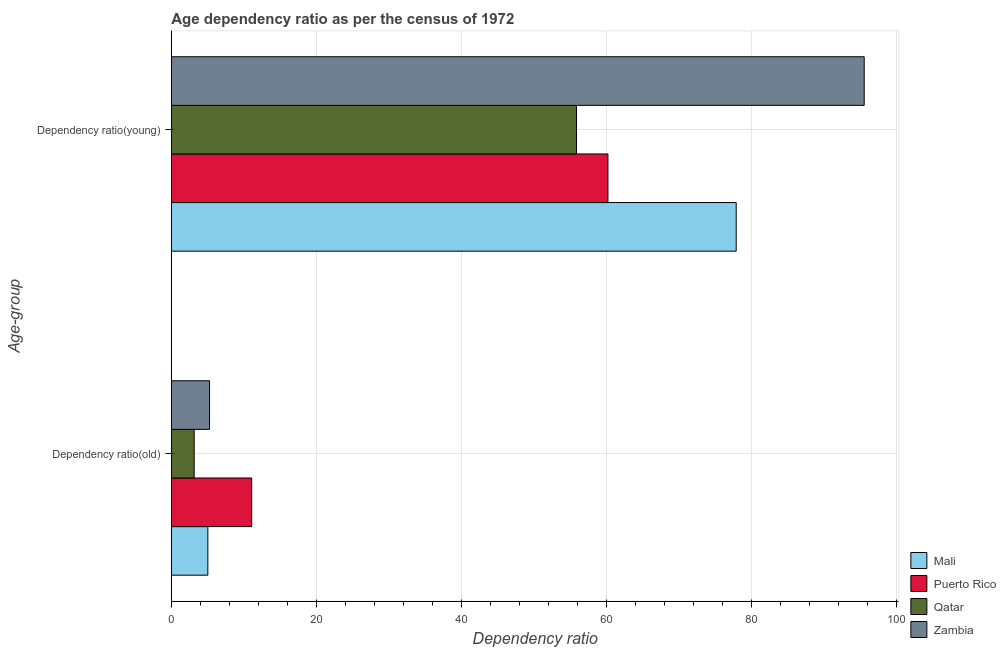How many different coloured bars are there?
Your answer should be very brief. 4. How many groups of bars are there?
Offer a terse response. 2. Are the number of bars per tick equal to the number of legend labels?
Give a very brief answer. Yes. Are the number of bars on each tick of the Y-axis equal?
Make the answer very short. Yes. How many bars are there on the 1st tick from the bottom?
Provide a succinct answer. 4. What is the label of the 1st group of bars from the top?
Make the answer very short. Dependency ratio(young). What is the age dependency ratio(old) in Mali?
Keep it short and to the point. 5.03. Across all countries, what is the maximum age dependency ratio(old)?
Provide a short and direct response. 11.08. Across all countries, what is the minimum age dependency ratio(old)?
Offer a terse response. 3.14. In which country was the age dependency ratio(old) maximum?
Offer a very short reply. Puerto Rico. In which country was the age dependency ratio(old) minimum?
Offer a terse response. Qatar. What is the total age dependency ratio(young) in the graph?
Keep it short and to the point. 289.58. What is the difference between the age dependency ratio(young) in Qatar and that in Zambia?
Your answer should be compact. -39.69. What is the difference between the age dependency ratio(young) in Puerto Rico and the age dependency ratio(old) in Mali?
Provide a succinct answer. 55.19. What is the average age dependency ratio(old) per country?
Keep it short and to the point. 6.13. What is the difference between the age dependency ratio(young) and age dependency ratio(old) in Zambia?
Your answer should be very brief. 90.3. What is the ratio of the age dependency ratio(old) in Puerto Rico to that in Zambia?
Your answer should be compact. 2.1. Is the age dependency ratio(young) in Zambia less than that in Qatar?
Your answer should be very brief. No. In how many countries, is the age dependency ratio(old) greater than the average age dependency ratio(old) taken over all countries?
Provide a succinct answer. 1. What does the 4th bar from the top in Dependency ratio(young) represents?
Give a very brief answer. Mali. What does the 1st bar from the bottom in Dependency ratio(young) represents?
Your answer should be very brief. Mali. Does the graph contain any zero values?
Ensure brevity in your answer.  No. Does the graph contain grids?
Keep it short and to the point. Yes. Where does the legend appear in the graph?
Give a very brief answer. Bottom right. What is the title of the graph?
Provide a short and direct response. Age dependency ratio as per the census of 1972. What is the label or title of the X-axis?
Offer a very short reply. Dependency ratio. What is the label or title of the Y-axis?
Offer a terse response. Age-group. What is the Dependency ratio of Mali in Dependency ratio(old)?
Provide a short and direct response. 5.03. What is the Dependency ratio in Puerto Rico in Dependency ratio(old)?
Make the answer very short. 11.08. What is the Dependency ratio in Qatar in Dependency ratio(old)?
Give a very brief answer. 3.14. What is the Dependency ratio in Zambia in Dependency ratio(old)?
Ensure brevity in your answer.  5.26. What is the Dependency ratio in Mali in Dependency ratio(young)?
Make the answer very short. 77.91. What is the Dependency ratio of Puerto Rico in Dependency ratio(young)?
Your answer should be very brief. 60.22. What is the Dependency ratio in Qatar in Dependency ratio(young)?
Provide a succinct answer. 55.88. What is the Dependency ratio of Zambia in Dependency ratio(young)?
Make the answer very short. 95.57. Across all Age-group, what is the maximum Dependency ratio in Mali?
Make the answer very short. 77.91. Across all Age-group, what is the maximum Dependency ratio of Puerto Rico?
Make the answer very short. 60.22. Across all Age-group, what is the maximum Dependency ratio of Qatar?
Offer a terse response. 55.88. Across all Age-group, what is the maximum Dependency ratio of Zambia?
Offer a very short reply. 95.57. Across all Age-group, what is the minimum Dependency ratio in Mali?
Offer a terse response. 5.03. Across all Age-group, what is the minimum Dependency ratio in Puerto Rico?
Your answer should be very brief. 11.08. Across all Age-group, what is the minimum Dependency ratio in Qatar?
Give a very brief answer. 3.14. Across all Age-group, what is the minimum Dependency ratio in Zambia?
Your answer should be very brief. 5.26. What is the total Dependency ratio of Mali in the graph?
Your answer should be compact. 82.94. What is the total Dependency ratio of Puerto Rico in the graph?
Your answer should be compact. 71.29. What is the total Dependency ratio of Qatar in the graph?
Keep it short and to the point. 59.03. What is the total Dependency ratio in Zambia in the graph?
Provide a short and direct response. 100.83. What is the difference between the Dependency ratio in Mali in Dependency ratio(old) and that in Dependency ratio(young)?
Give a very brief answer. -72.88. What is the difference between the Dependency ratio of Puerto Rico in Dependency ratio(old) and that in Dependency ratio(young)?
Make the answer very short. -49.14. What is the difference between the Dependency ratio in Qatar in Dependency ratio(old) and that in Dependency ratio(young)?
Give a very brief answer. -52.74. What is the difference between the Dependency ratio of Zambia in Dependency ratio(old) and that in Dependency ratio(young)?
Offer a terse response. -90.3. What is the difference between the Dependency ratio of Mali in Dependency ratio(old) and the Dependency ratio of Puerto Rico in Dependency ratio(young)?
Offer a terse response. -55.19. What is the difference between the Dependency ratio of Mali in Dependency ratio(old) and the Dependency ratio of Qatar in Dependency ratio(young)?
Offer a very short reply. -50.85. What is the difference between the Dependency ratio in Mali in Dependency ratio(old) and the Dependency ratio in Zambia in Dependency ratio(young)?
Give a very brief answer. -90.54. What is the difference between the Dependency ratio in Puerto Rico in Dependency ratio(old) and the Dependency ratio in Qatar in Dependency ratio(young)?
Ensure brevity in your answer.  -44.81. What is the difference between the Dependency ratio in Puerto Rico in Dependency ratio(old) and the Dependency ratio in Zambia in Dependency ratio(young)?
Offer a terse response. -84.49. What is the difference between the Dependency ratio in Qatar in Dependency ratio(old) and the Dependency ratio in Zambia in Dependency ratio(young)?
Offer a very short reply. -92.42. What is the average Dependency ratio in Mali per Age-group?
Ensure brevity in your answer.  41.47. What is the average Dependency ratio of Puerto Rico per Age-group?
Offer a terse response. 35.65. What is the average Dependency ratio in Qatar per Age-group?
Give a very brief answer. 29.51. What is the average Dependency ratio in Zambia per Age-group?
Provide a succinct answer. 50.42. What is the difference between the Dependency ratio in Mali and Dependency ratio in Puerto Rico in Dependency ratio(old)?
Make the answer very short. -6.05. What is the difference between the Dependency ratio of Mali and Dependency ratio of Qatar in Dependency ratio(old)?
Your response must be concise. 1.89. What is the difference between the Dependency ratio of Mali and Dependency ratio of Zambia in Dependency ratio(old)?
Your answer should be compact. -0.24. What is the difference between the Dependency ratio of Puerto Rico and Dependency ratio of Qatar in Dependency ratio(old)?
Provide a succinct answer. 7.93. What is the difference between the Dependency ratio in Puerto Rico and Dependency ratio in Zambia in Dependency ratio(old)?
Provide a succinct answer. 5.81. What is the difference between the Dependency ratio in Qatar and Dependency ratio in Zambia in Dependency ratio(old)?
Keep it short and to the point. -2.12. What is the difference between the Dependency ratio in Mali and Dependency ratio in Puerto Rico in Dependency ratio(young)?
Your answer should be very brief. 17.69. What is the difference between the Dependency ratio in Mali and Dependency ratio in Qatar in Dependency ratio(young)?
Offer a very short reply. 22.03. What is the difference between the Dependency ratio in Mali and Dependency ratio in Zambia in Dependency ratio(young)?
Provide a short and direct response. -17.66. What is the difference between the Dependency ratio of Puerto Rico and Dependency ratio of Qatar in Dependency ratio(young)?
Ensure brevity in your answer.  4.34. What is the difference between the Dependency ratio of Puerto Rico and Dependency ratio of Zambia in Dependency ratio(young)?
Your answer should be very brief. -35.35. What is the difference between the Dependency ratio of Qatar and Dependency ratio of Zambia in Dependency ratio(young)?
Offer a very short reply. -39.69. What is the ratio of the Dependency ratio in Mali in Dependency ratio(old) to that in Dependency ratio(young)?
Provide a short and direct response. 0.06. What is the ratio of the Dependency ratio of Puerto Rico in Dependency ratio(old) to that in Dependency ratio(young)?
Your response must be concise. 0.18. What is the ratio of the Dependency ratio in Qatar in Dependency ratio(old) to that in Dependency ratio(young)?
Provide a succinct answer. 0.06. What is the ratio of the Dependency ratio of Zambia in Dependency ratio(old) to that in Dependency ratio(young)?
Make the answer very short. 0.06. What is the difference between the highest and the second highest Dependency ratio of Mali?
Your answer should be very brief. 72.88. What is the difference between the highest and the second highest Dependency ratio in Puerto Rico?
Ensure brevity in your answer.  49.14. What is the difference between the highest and the second highest Dependency ratio in Qatar?
Give a very brief answer. 52.74. What is the difference between the highest and the second highest Dependency ratio in Zambia?
Make the answer very short. 90.3. What is the difference between the highest and the lowest Dependency ratio of Mali?
Offer a very short reply. 72.88. What is the difference between the highest and the lowest Dependency ratio of Puerto Rico?
Ensure brevity in your answer.  49.14. What is the difference between the highest and the lowest Dependency ratio in Qatar?
Your answer should be compact. 52.74. What is the difference between the highest and the lowest Dependency ratio in Zambia?
Your answer should be compact. 90.3. 